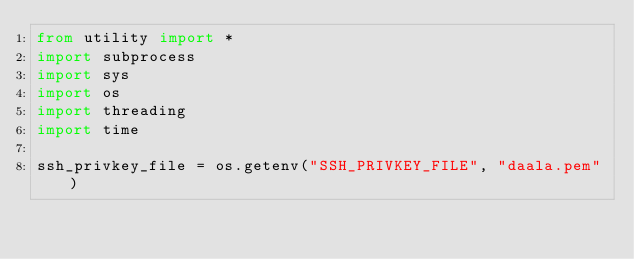Convert code to text. <code><loc_0><loc_0><loc_500><loc_500><_Python_>from utility import *
import subprocess
import sys
import os
import threading
import time

ssh_privkey_file = os.getenv("SSH_PRIVKEY_FILE", "daala.pem")
</code> 